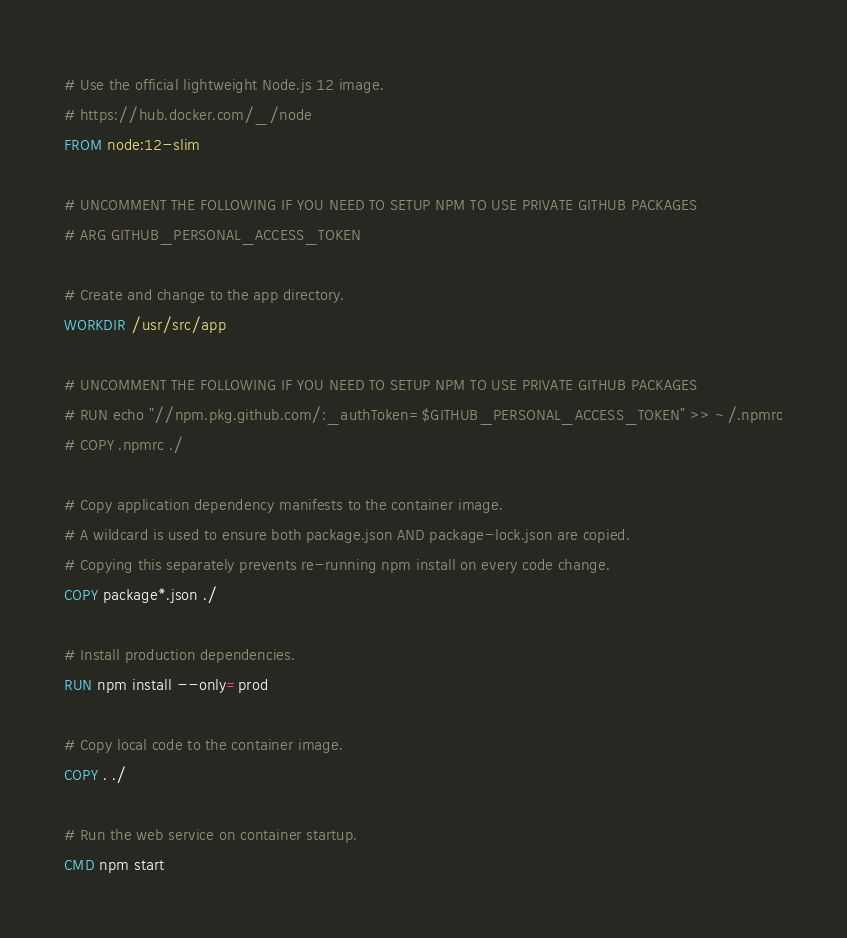Convert code to text. <code><loc_0><loc_0><loc_500><loc_500><_Dockerfile_># Use the official lightweight Node.js 12 image.
# https://hub.docker.com/_/node
FROM node:12-slim

# UNCOMMENT THE FOLLOWING IF YOU NEED TO SETUP NPM TO USE PRIVATE GITHUB PACKAGES
# ARG GITHUB_PERSONAL_ACCESS_TOKEN

# Create and change to the app directory.
WORKDIR /usr/src/app

# UNCOMMENT THE FOLLOWING IF YOU NEED TO SETUP NPM TO USE PRIVATE GITHUB PACKAGES
# RUN echo "//npm.pkg.github.com/:_authToken=$GITHUB_PERSONAL_ACCESS_TOKEN" >> ~/.npmrc
# COPY .npmrc ./

# Copy application dependency manifests to the container image.
# A wildcard is used to ensure both package.json AND package-lock.json are copied.
# Copying this separately prevents re-running npm install on every code change.
COPY package*.json ./

# Install production dependencies.
RUN npm install --only=prod

# Copy local code to the container image.
COPY . ./

# Run the web service on container startup.
CMD npm start
</code> 